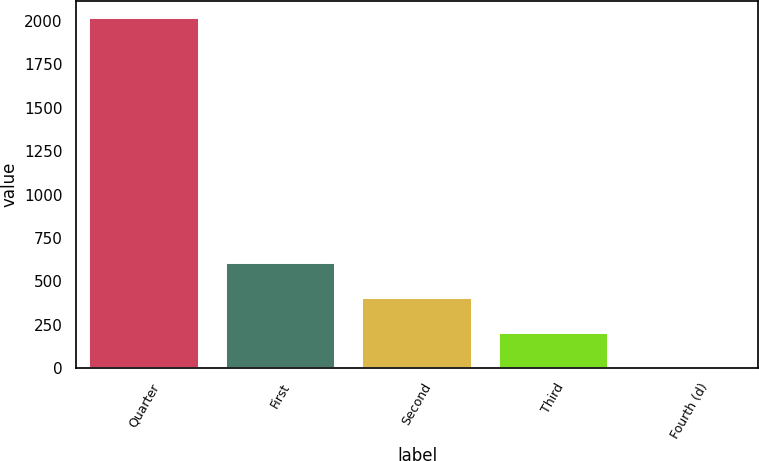Convert chart. <chart><loc_0><loc_0><loc_500><loc_500><bar_chart><fcel>Quarter<fcel>First<fcel>Second<fcel>Third<fcel>Fourth (d)<nl><fcel>2016<fcel>605.5<fcel>404<fcel>202.5<fcel>1<nl></chart> 